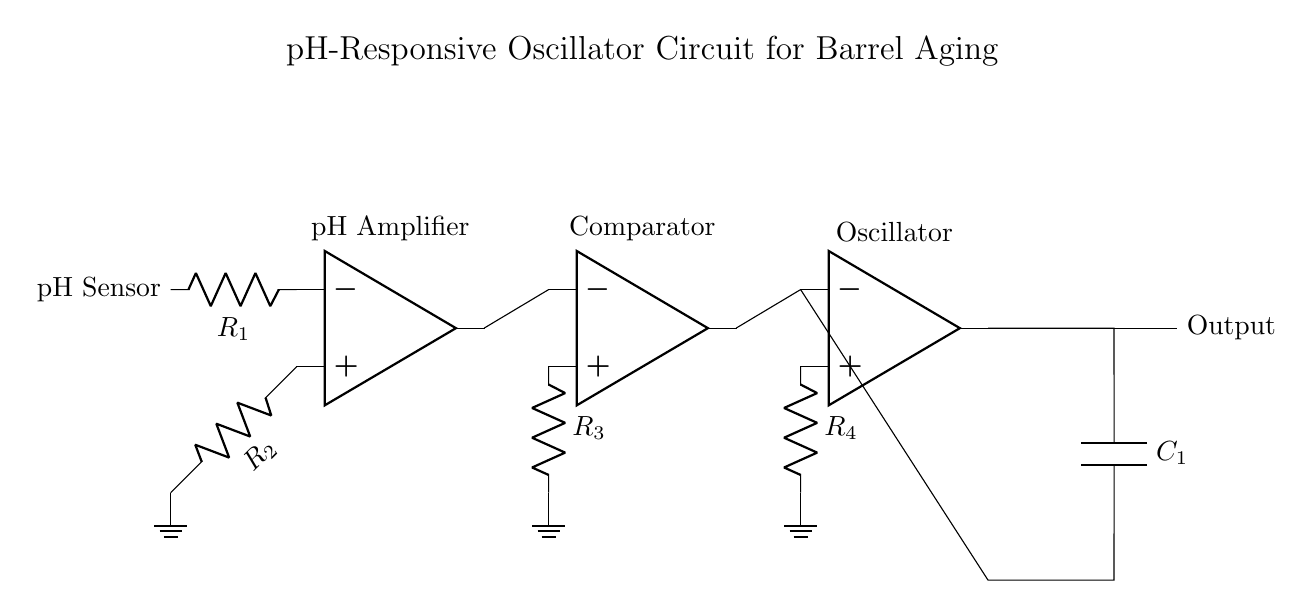What type of components are present in the circuit? The circuit consists of operational amplifiers, resistors, and a capacitor. These are indicated by the symbols representing each component: op amp for amplifiers, R for resistors, and C for the capacitor.
Answer: operational amplifiers, resistors, capacitor What is the purpose of the pH sensor in the circuit? The pH sensor measures the acidity of the solution, providing an input signal to be amplified and processed by the oscillator circuit. Its placement near the input of the op amp indicates its role in sensing the acidity.
Answer: acidity measurement How many resistors are used in the circuit? The diagram shows four resistors: R1, R2, R3, and R4, which are used in different parts of the circuit for various functions like amplification and feedback.
Answer: four What is the output of the oscillator labeled as? The output of the oscillator is simply labeled "Output," suggesting that this is where the final signal can be observed or measured.
Answer: Output What role does the comparator have in this circuit? The comparator is used to compare the output from the pH amplifier with a reference voltage, and it drives the next stage of the oscillator, determining the oscillation behavior based on the input signal from the pH sensor.
Answer: compare pH signal How does the oscillator function in response to pH changes? The oscillator generates a frequency-based signal that varies according to the changes in pH detected by the sensor, with its operation driven by the changes in the input voltage from the comparator, which reflects the acidity levels.
Answer: frequency generation What is the significance of the capacitor in the oscillator circuit? The capacitor is critical for creating the timing elements needed for oscillation by charging and discharging, determining the frequency of oscillation depending on its value and the connected resistors.
Answer: timing element 